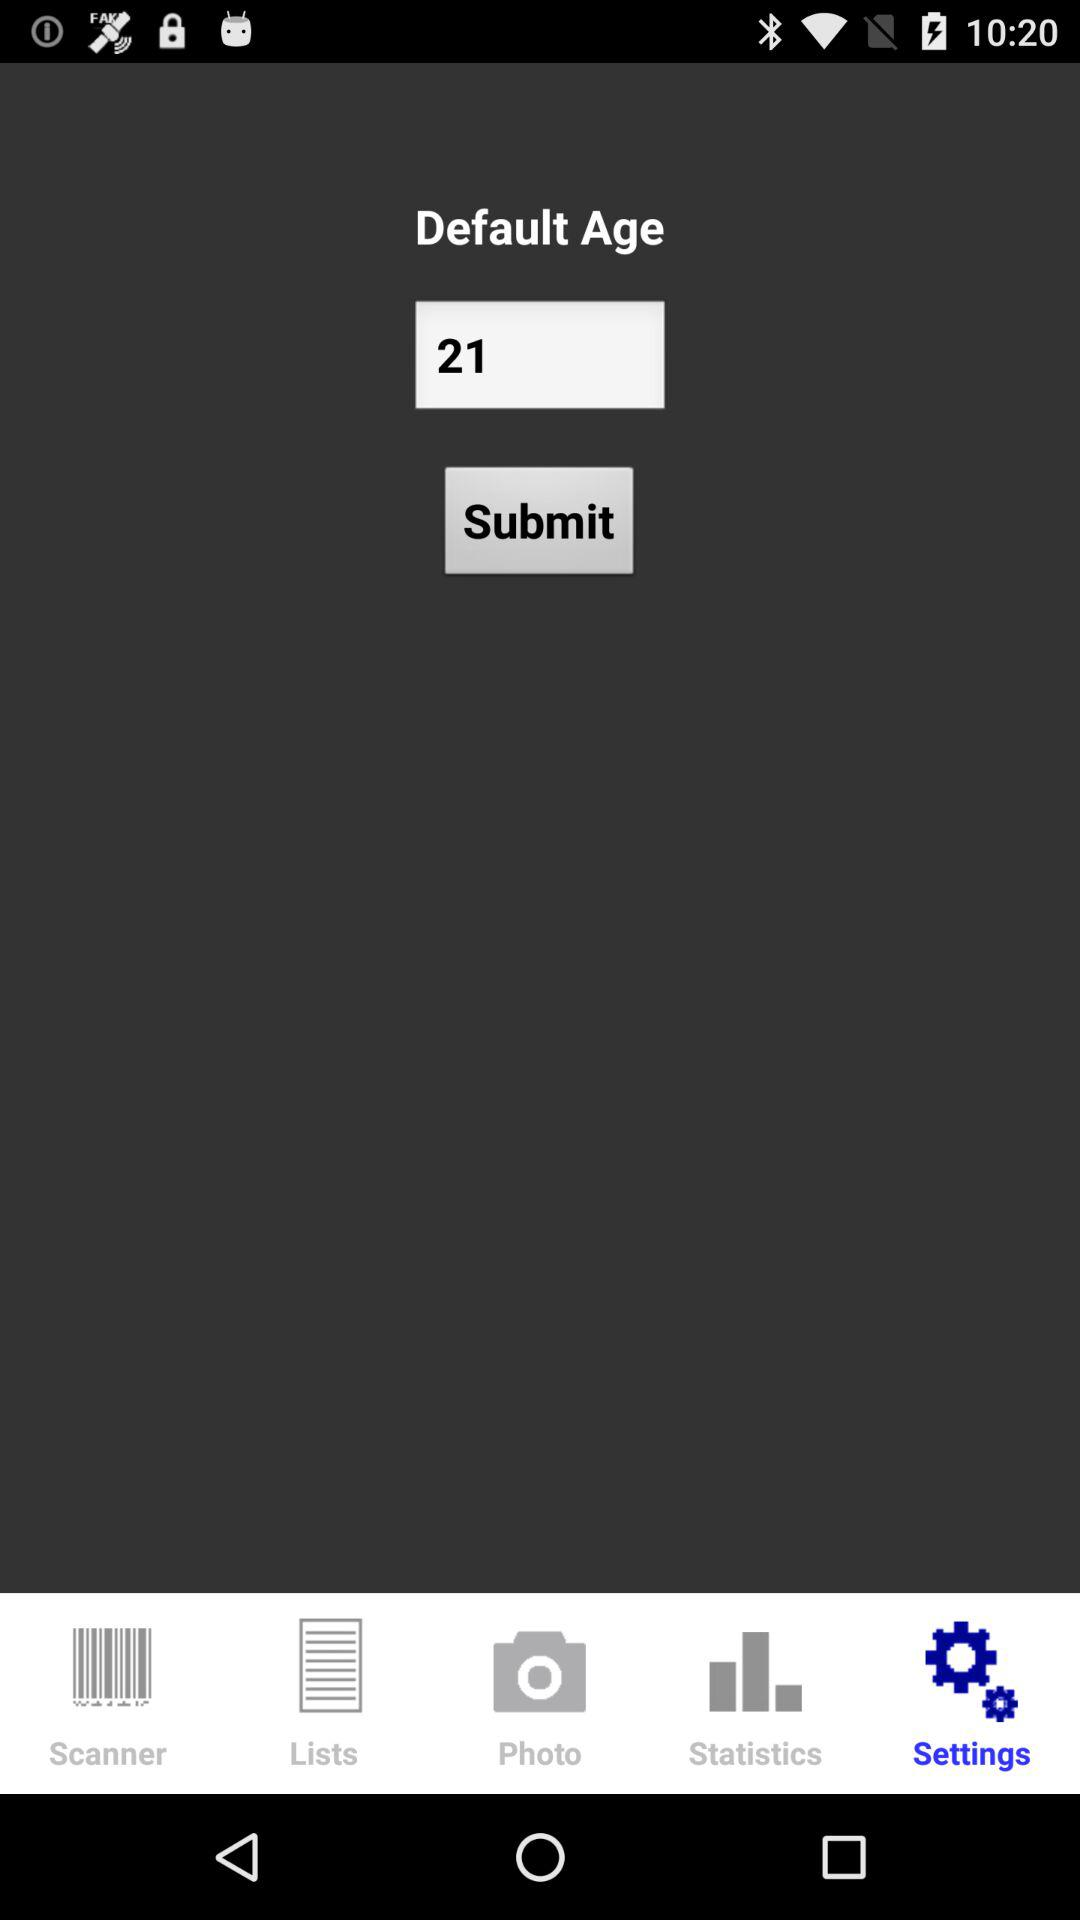Which tab is currently selected? The currently selected tab is "Settings". 